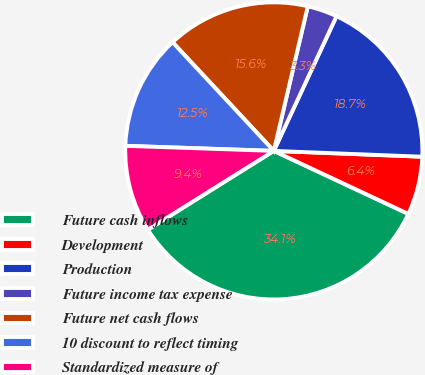<chart> <loc_0><loc_0><loc_500><loc_500><pie_chart><fcel>Future cash inflows<fcel>Development<fcel>Production<fcel>Future income tax expense<fcel>Future net cash flows<fcel>10 discount to reflect timing<fcel>Standardized measure of<nl><fcel>34.13%<fcel>6.35%<fcel>18.69%<fcel>3.26%<fcel>15.61%<fcel>12.52%<fcel>9.44%<nl></chart> 